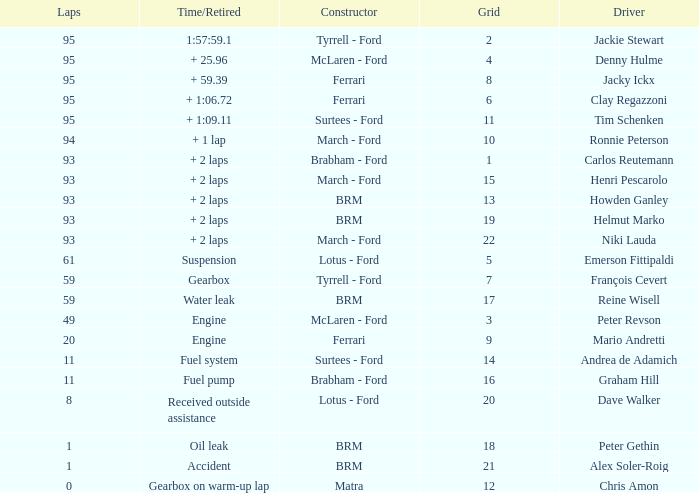Can you give me this table as a dict? {'header': ['Laps', 'Time/Retired', 'Constructor', 'Grid', 'Driver'], 'rows': [['95', '1:57:59.1', 'Tyrrell - Ford', '2', 'Jackie Stewart'], ['95', '+ 25.96', 'McLaren - Ford', '4', 'Denny Hulme'], ['95', '+ 59.39', 'Ferrari', '8', 'Jacky Ickx'], ['95', '+ 1:06.72', 'Ferrari', '6', 'Clay Regazzoni'], ['95', '+ 1:09.11', 'Surtees - Ford', '11', 'Tim Schenken'], ['94', '+ 1 lap', 'March - Ford', '10', 'Ronnie Peterson'], ['93', '+ 2 laps', 'Brabham - Ford', '1', 'Carlos Reutemann'], ['93', '+ 2 laps', 'March - Ford', '15', 'Henri Pescarolo'], ['93', '+ 2 laps', 'BRM', '13', 'Howden Ganley'], ['93', '+ 2 laps', 'BRM', '19', 'Helmut Marko'], ['93', '+ 2 laps', 'March - Ford', '22', 'Niki Lauda'], ['61', 'Suspension', 'Lotus - Ford', '5', 'Emerson Fittipaldi'], ['59', 'Gearbox', 'Tyrrell - Ford', '7', 'François Cevert'], ['59', 'Water leak', 'BRM', '17', 'Reine Wisell'], ['49', 'Engine', 'McLaren - Ford', '3', 'Peter Revson'], ['20', 'Engine', 'Ferrari', '9', 'Mario Andretti'], ['11', 'Fuel system', 'Surtees - Ford', '14', 'Andrea de Adamich'], ['11', 'Fuel pump', 'Brabham - Ford', '16', 'Graham Hill'], ['8', 'Received outside assistance', 'Lotus - Ford', '20', 'Dave Walker'], ['1', 'Oil leak', 'BRM', '18', 'Peter Gethin'], ['1', 'Accident', 'BRM', '21', 'Alex Soler-Roig'], ['0', 'Gearbox on warm-up lap', 'Matra', '12', 'Chris Amon']]} How many grids does dave walker have? 1.0. 